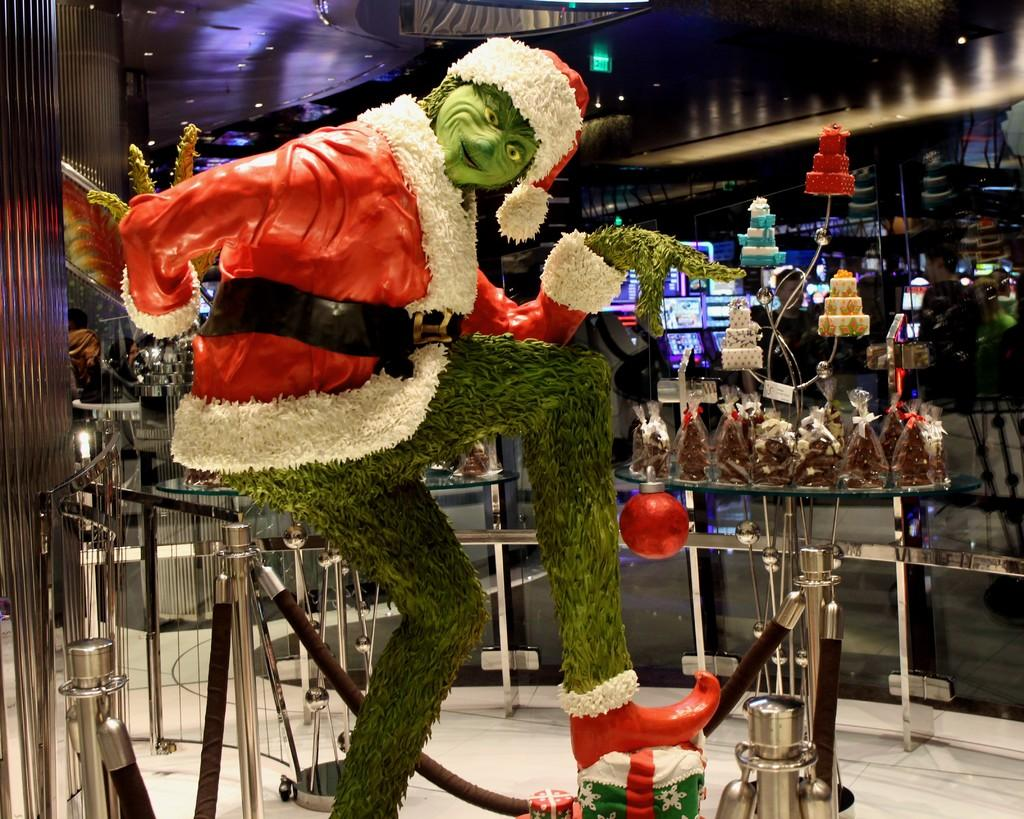What is the main subject in the center of the image? There is a statue in the center of the image. What can be seen in the background of the image? There are stands, chains, and food items visible in the background of the image. What type of lighting is present in the image? There are lights at the top of the image. What architectural feature is present in the image? There is a roof in the image. What type of sticks are being used to stir the kettle in the image? There is no kettle or sticks present in the image. How many pails of water are visible in the image? There are no pails of water visible in the image. 